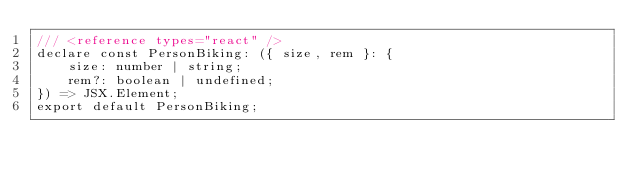Convert code to text. <code><loc_0><loc_0><loc_500><loc_500><_TypeScript_>/// <reference types="react" />
declare const PersonBiking: ({ size, rem }: {
    size: number | string;
    rem?: boolean | undefined;
}) => JSX.Element;
export default PersonBiking;
</code> 